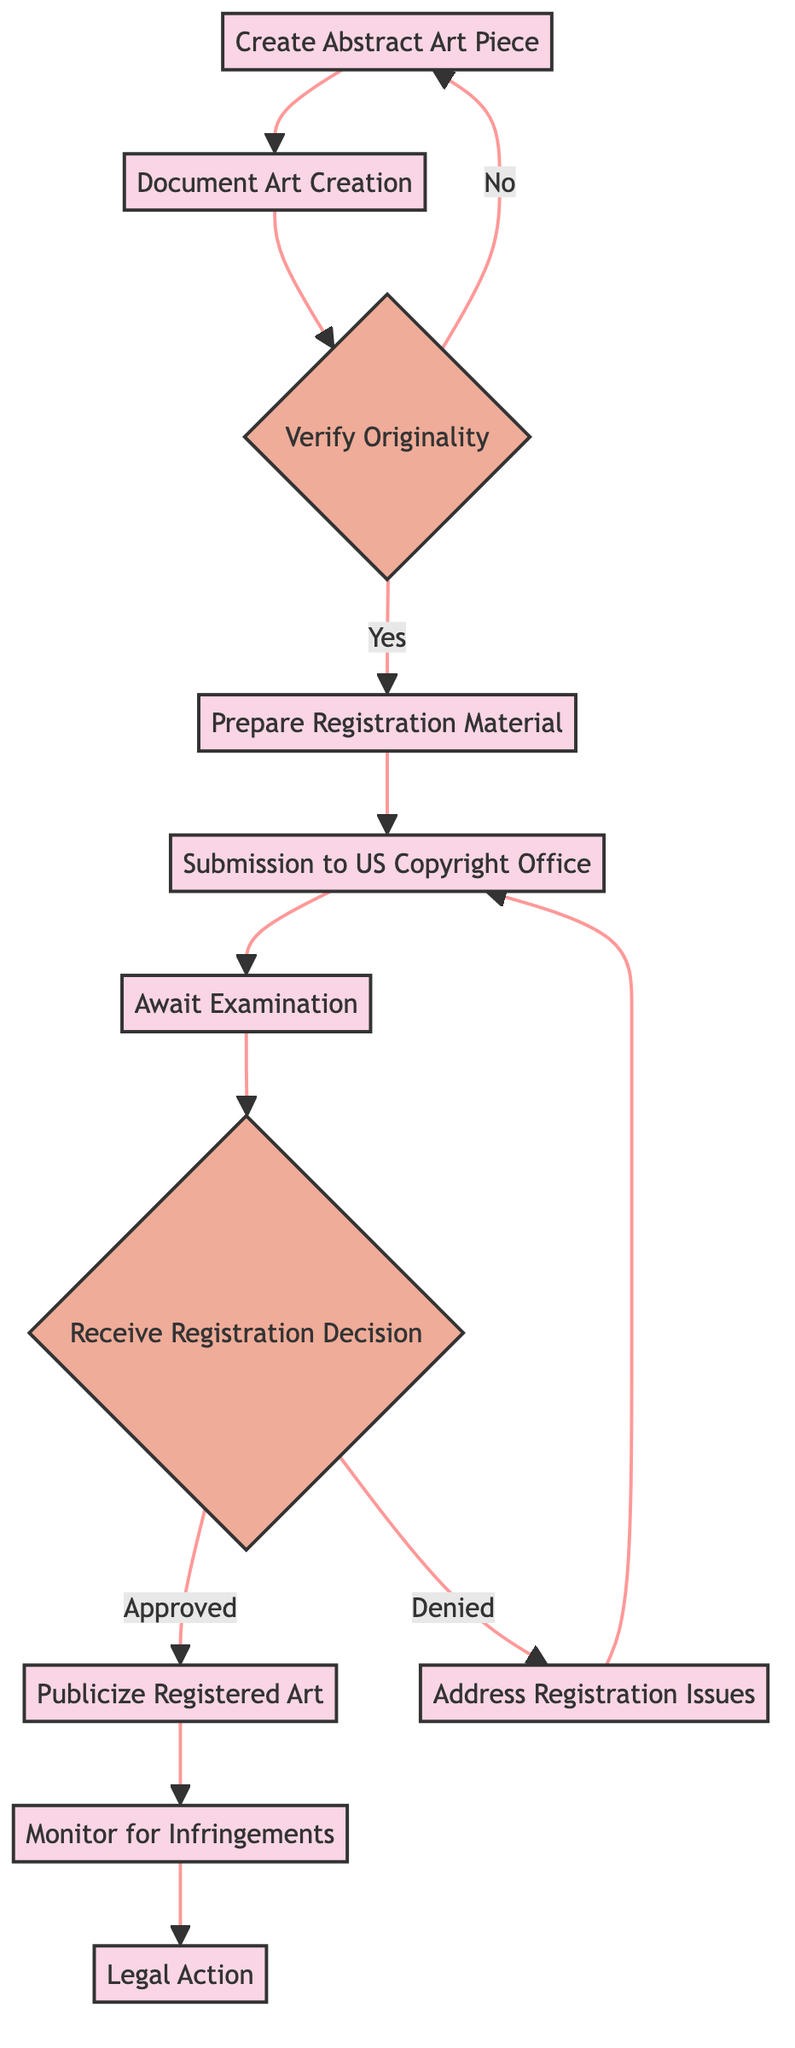What is the first step in the workflow? The diagram indicates that the first step is labeled "Create Abstract Art Piece." It is the initial process that begins the workflow.
Answer: Create Abstract Art Piece What is the outcome if the originality check fails? According to the diagram, if the originality check fails, the process routes back to "Create Abstract Art Piece," indicating that the artist needs to revise their artwork.
Answer: Revise Art Piece How many decision nodes are present in the flowchart? The flowchart contains two decision nodes: "Verify Originality" and "Receive Registration Decision." These are the points where different outcomes are determined.
Answer: 2 What follows the "Await Examination" step? The diagram shows that after "Await Examination," the next step is "Receive Registration Decision,” meaning that the examination will yield a decision regarding the submission.
Answer: Receive Registration Decision What action should be taken after receiving a registration denial? The diagram specifies that if registration is denied, the next action is to "Address Registration Issues" to resolve any problems before resubmitting.
Answer: Address Registration Issues What is the final step in the flowchart? The final step shown in the flowchart is "Legal Action," which occurs after monitoring for infringements. This indicates that legal recourse is available if copyright violations are identified.
Answer: Legal Action What happens after successful registration of the artwork? After the artwork is successfully registered, the next step is to "Publicize Registered Art," which means that the artist can begin promoting their work.
Answer: Publicize Registered Art What is the purpose of documenting the art creation? The diagram indicates that documenting the art creation is important for ensuring there is a record of the process and materials used, which contributes to the proof of authorship in case of disputes.
Answer: Proof of authorship How do you know when to resubmit the registration? The flowchart states that if there are issues with the registration, the step "Address Registration Issues" leads back to "Submission to US Copyright Office," indicating it's time to resubmit after resolving any concerns.
Answer: Resubmit Registration 